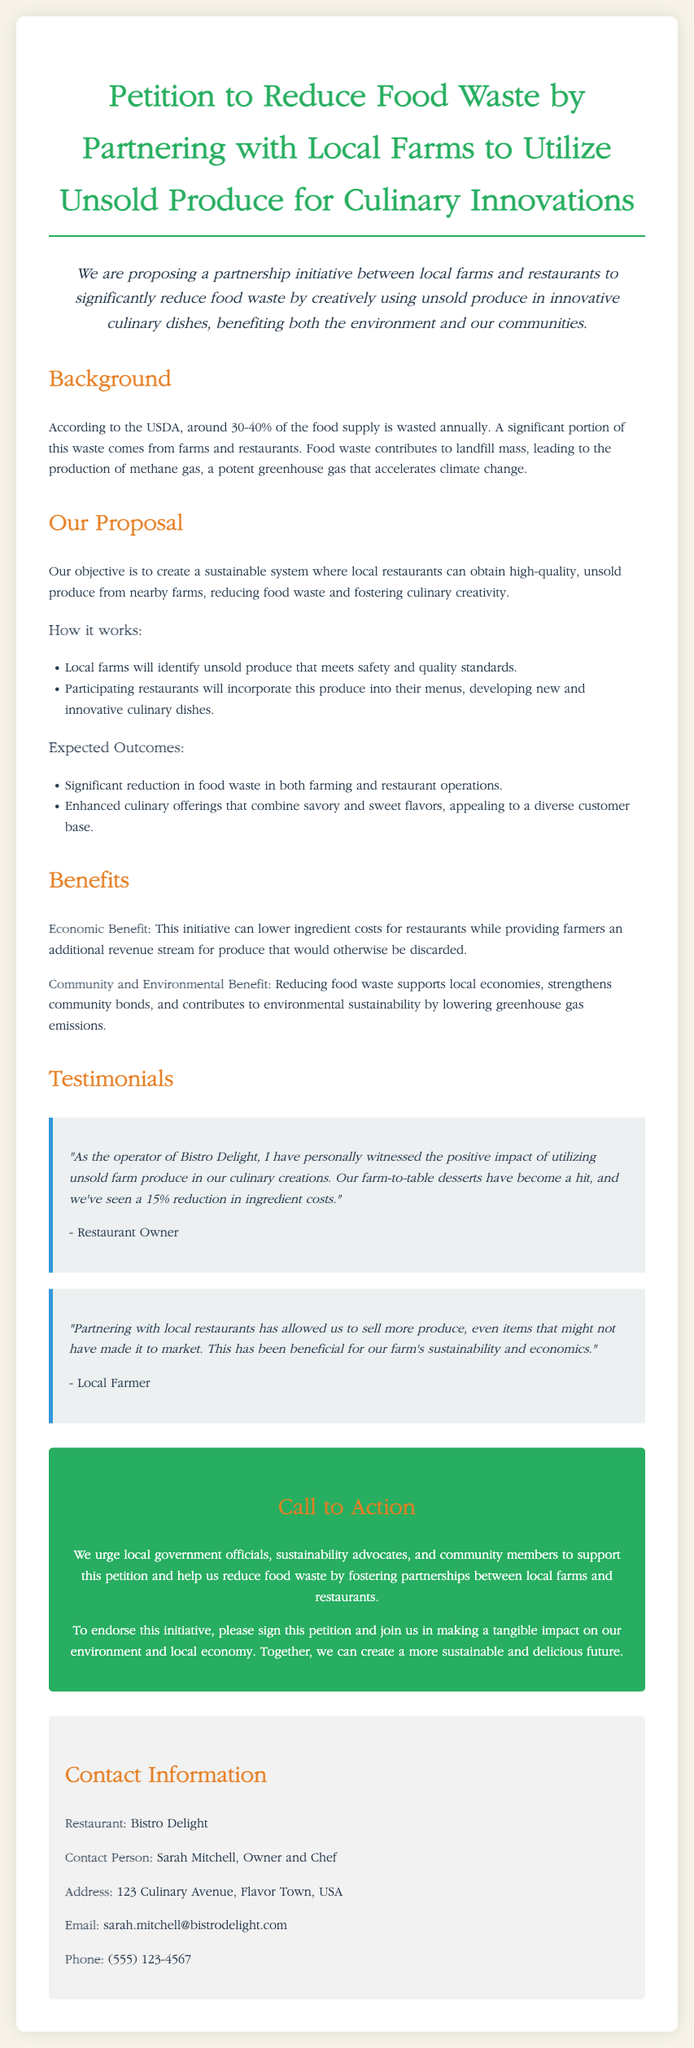what is the title of the petition? The title of the petition is presented prominently at the top and describes the main focus of the initiative.
Answer: Petition to Reduce Food Waste by Partnering with Local Farms to Utilize Unsold Produce for Culinary Innovations how much of the food supply is wasted annually according to the USDA? The document provides a statistic regarding food waste which highlights the significance of the issue addressed in the petition.
Answer: 30-40% who is the contact person for the petition? The petition includes contact details, specifying the individual responsible for the initiative.
Answer: Sarah Mitchell what is one expected outcome of the proposal? The proposal outlines specific expected benefits, providing details about the positive changes that could result from the initiative.
Answer: Significant reduction in food waste in both farming and restaurant operations which restaurant owner provided a testimonial in the document? The testimonials section of the petition includes quotes from individuals supporting the initiative, highlighting personal experiences.
Answer: Bistro Delight what is the email address provided for contact? The contact information section includes specific details for reaching out regarding the petition, including electronic communication.
Answer: sarah.mitchell@bistrodelight.com what benefit does the initiative provide to local farms? The petition discusses benefits to both restaurants and local farms, indicating economic advantages for one of the parties involved.
Answer: Additional revenue stream how does the initiative contribute to environmental sustainability? The petition connects food waste reduction to larger environmental issues, underlining the initiative's impact on sustainability.
Answer: Lowering greenhouse gas emissions 